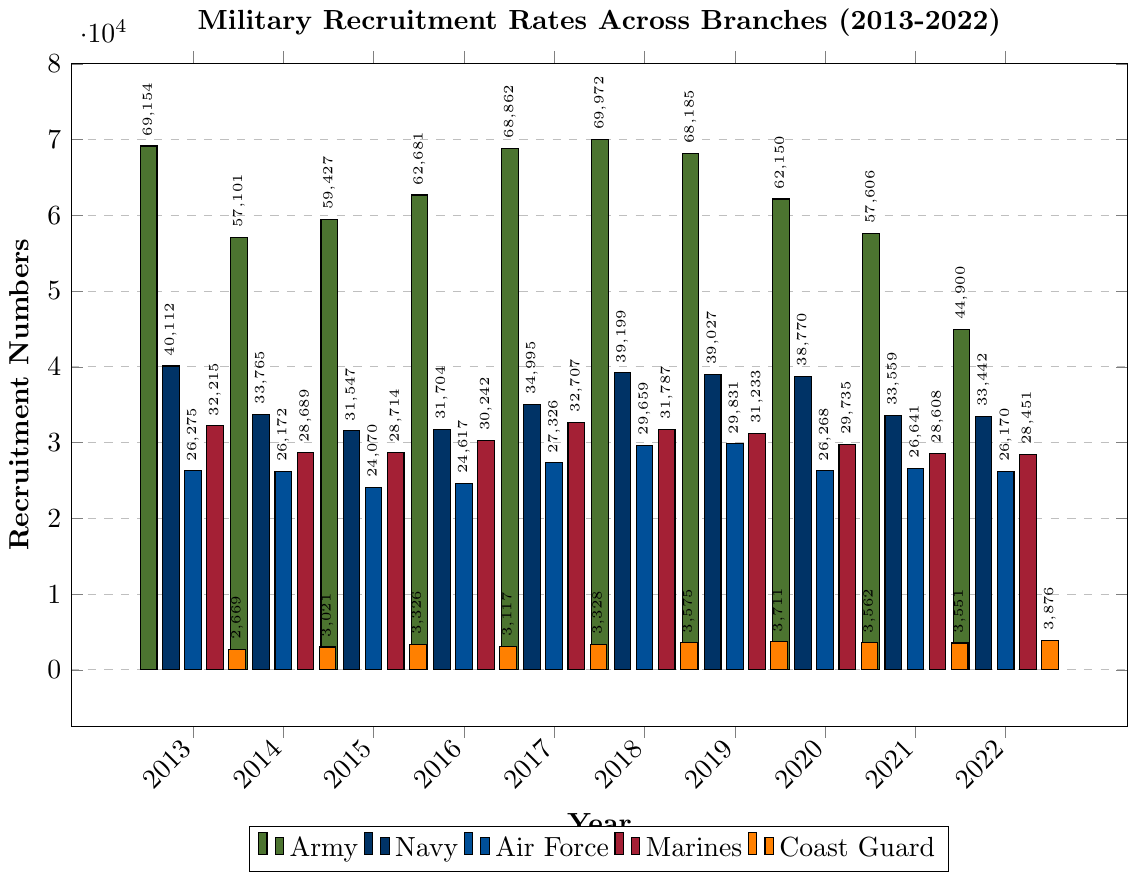What was the trend in Army recruitment over the decade? To identify the trend, observe the heights of the green bars for the 'Army' across the years 2013 to 2022. The heights show the following changes yearly: decreasing from 2013 to 2014, a slight increase in 2015 and 2016, then a peak in 2018, followed by a general decline to the lowest in 2022.
Answer: Decreasing trend overall Which year had the highest recruitment for the Navy Reserve? Look at the navy blue bars for the Navy Reserve. By comparing the heights, the highest bar is in 2019.
Answer: 2019 How did Marine Corps recruitment compare to Marine Corps Reserve recruitment in 2017? Compare the height of the maroon bar ('Marines') to the height of the light maroon bar ('Marine Corps Reserve') in the year 2017. The 'Marines' bar is significantly higher.
Answer: Marines higher Calculate the average Coast Guard recruitment over the decade. Sum the values for Coast Guard over 2013-2022 and divide by 10. \((2669 + 3021 + 3326 + 3117 + 3328 + 3575 + 3711 + 3562 + 3551 + 3876) / 10 = 3373.6\)
Answer: 3373.6 Which two branches showed a significant decline in recruitment from 2013 to 2022? Compare the first and last bars for each branch between 2013 and 2022. Army decreased from 69154 to 44900, and Army Reserve from 15568 to 10800 show the significant declines.
Answer: Army, Army Reserve In which year did the Air Force have its highest recruitment rate? Look at the blue bars for the Air Force and find the highest bar, which occurs in 2019.
Answer: 2019 What is the combined recruitment for all branches in 2016? Add the recruitment numbers for all branches in 2016: \( 62681 + 15199 + 31704 + 8356 + 24617 + 6340 + 30242 + 6724 + 3117 + 1303 = 189283 \)
Answer: 189283 Which branch had the most consistent recruitment rate over the decade, excluding reserves? Observe the height of bars and their changes for the main branches, excluding reserves. The Coast Guard (orange bars) shows the most stability with minor changes each year.
Answer: Coast Guard Which reserve component had the highest recruitment in 2020? Compare the bar heights of all reserve components for the year 2020. Navy Reserve (bar in navy blue) is the highest.
Answer: Navy Reserve How does the Air Force Reserve recruitment in 2022 compare to 2013? Compare the heights of the light blue bars for Air Force Reserve in 2013 and 2022, which are 5746 and 5761 respectively, indicating a very minimal increase.
Answer: Nearly equal 